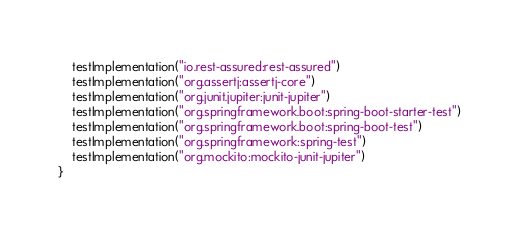Convert code to text. <code><loc_0><loc_0><loc_500><loc_500><_Kotlin_>    testImplementation("io.rest-assured:rest-assured")
    testImplementation("org.assertj:assertj-core")
    testImplementation("org.junit.jupiter:junit-jupiter")
    testImplementation("org.springframework.boot:spring-boot-starter-test")
    testImplementation("org.springframework.boot:spring-boot-test")
    testImplementation("org.springframework:spring-test")
    testImplementation("org.mockito:mockito-junit-jupiter")
}</code> 